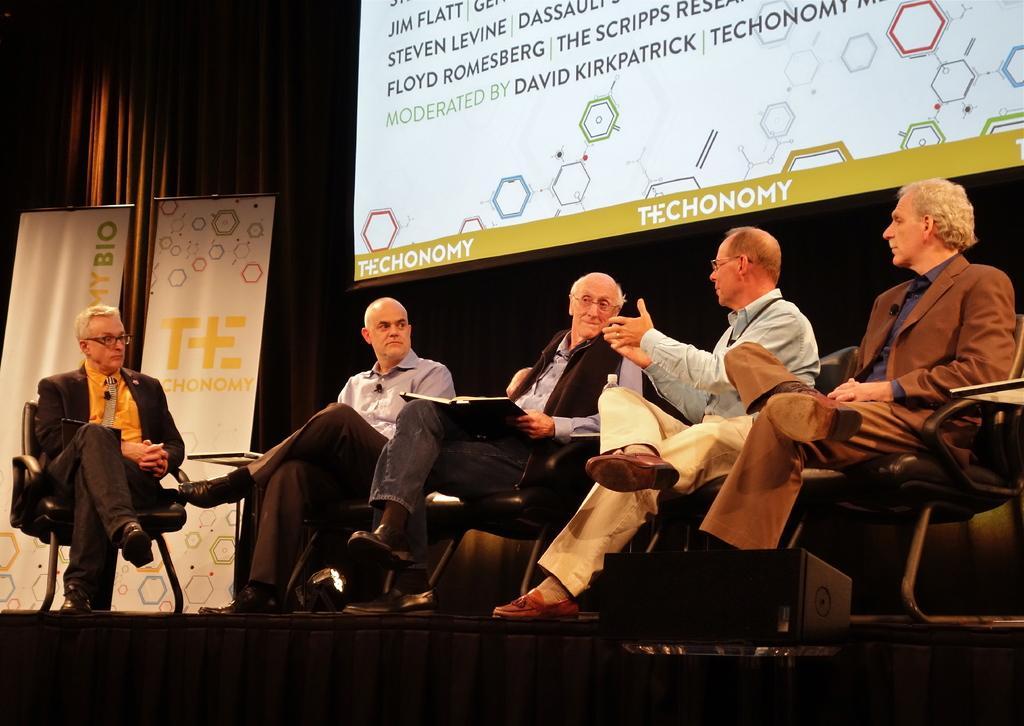Describe this image in one or two sentences. In the picture we can see four men are sitting on the chairs and they are discussing and talking to each other and beside them, we can see a man sitting in a blazer, tie and shirt and behind the men we can see a part of the screen with some information and beside it we can see two banners and behind it we can see the curtain. 